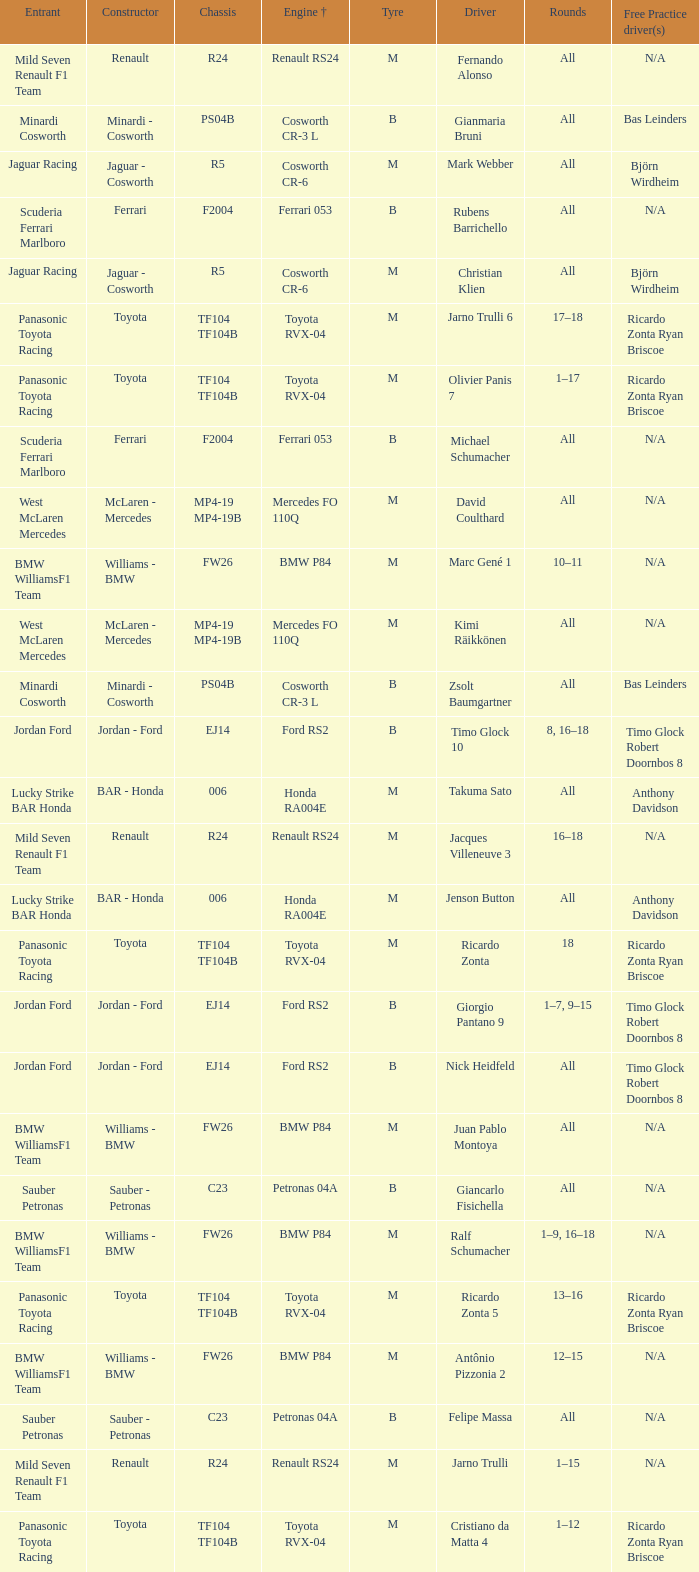What kind of chassis does Ricardo Zonta have? TF104 TF104B. 